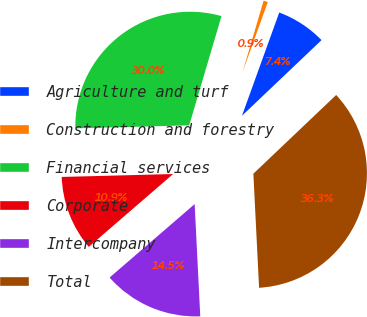<chart> <loc_0><loc_0><loc_500><loc_500><pie_chart><fcel>Agriculture and turf<fcel>Construction and forestry<fcel>Financial services<fcel>Corporate<fcel>Intercompany<fcel>Total<nl><fcel>7.39%<fcel>0.94%<fcel>29.99%<fcel>10.92%<fcel>14.46%<fcel>36.3%<nl></chart> 